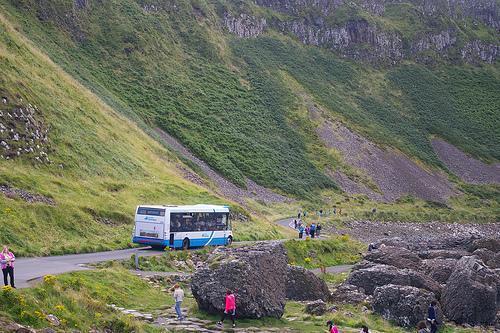How many buses are there?
Give a very brief answer. 1. 